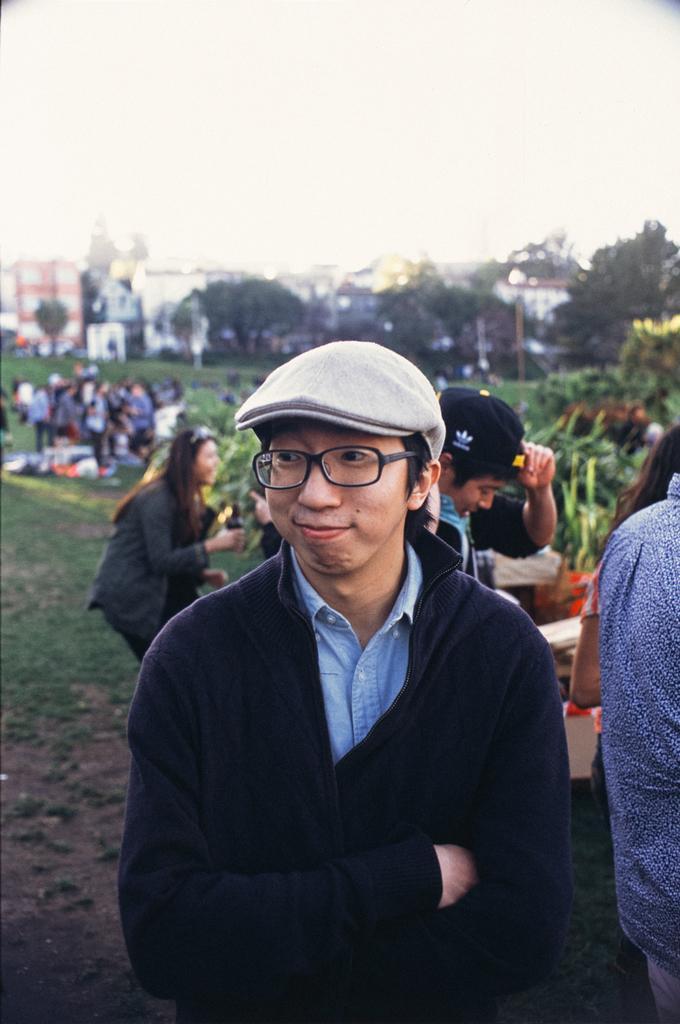Could you give a brief overview of what you see in this image? This is the man standing and smiling. He wore a cap, spectacles, jerkin and a shirt. In the background, I can see groups of people standing. This is the grass. These are the trees and buildings. 